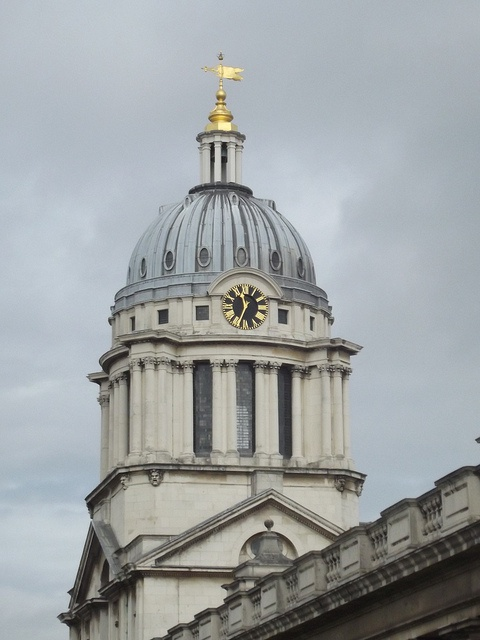Describe the objects in this image and their specific colors. I can see a clock in darkgray, black, khaki, gray, and tan tones in this image. 